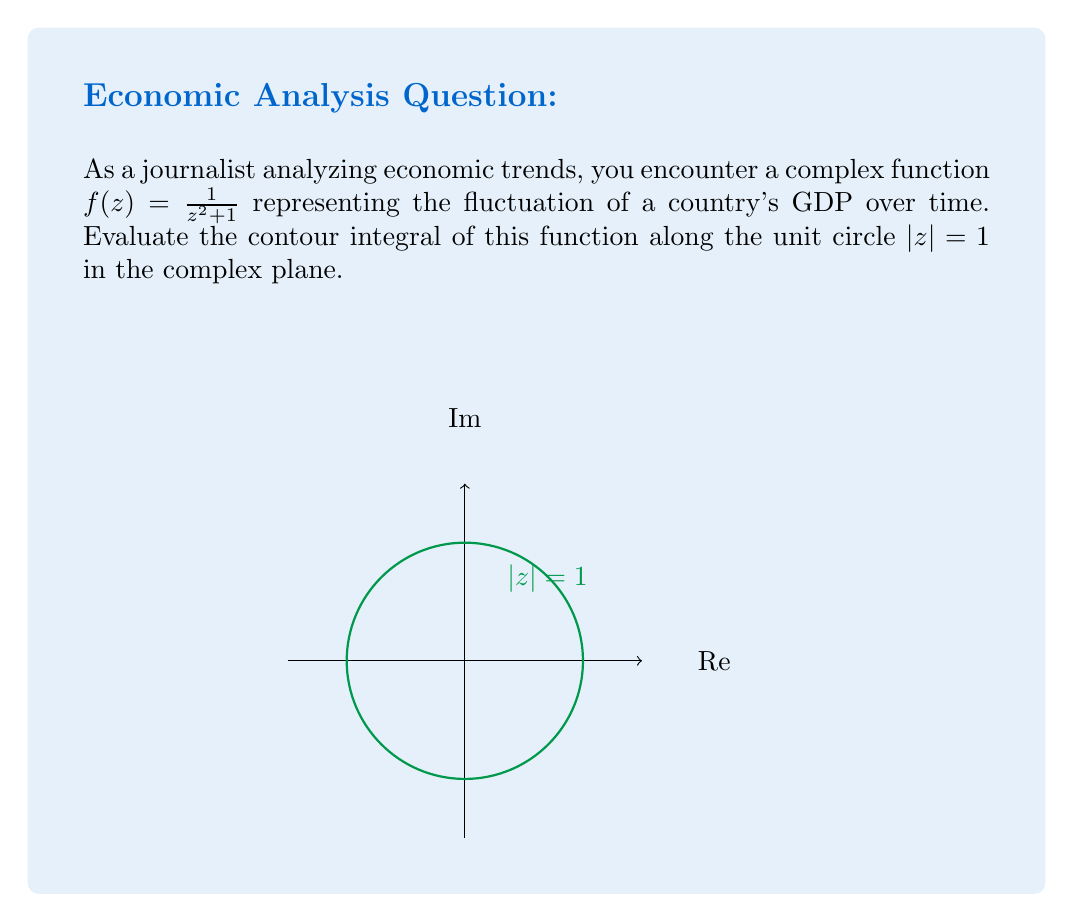Can you answer this question? Let's approach this step-by-step:

1) We're evaluating $\oint_{|z|=1} \frac{1}{z^2 + 1} dz$.

2) To use the Residue Theorem, we need to find the residues of $f(z)$ inside the unit circle.

3) The poles of $f(z)$ are at $z = \pm i$. Only $z = i$ is inside the unit circle.

4) To find the residue at $z = i$, we use:

   $$\text{Res}(f, i) = \lim_{z \to i} (z-i)f(z) = \lim_{z \to i} \frac{z-i}{z^2+1}$$

5) Apply L'Hôpital's rule:

   $$\lim_{z \to i} \frac{1}{2z} = \frac{1}{2i}$$

6) The Residue Theorem states:

   $$\oint_{|z|=1} f(z) dz = 2\pi i \sum \text{Res}(f, a_k)$$

   where $a_k$ are the poles inside the contour.

7) Applying the theorem:

   $$\oint_{|z|=1} \frac{1}{z^2 + 1} dz = 2\pi i \cdot \frac{1}{2i} = \pi$$

This result represents the net change in the economic indicator over one complete cycle.
Answer: $\pi$ 